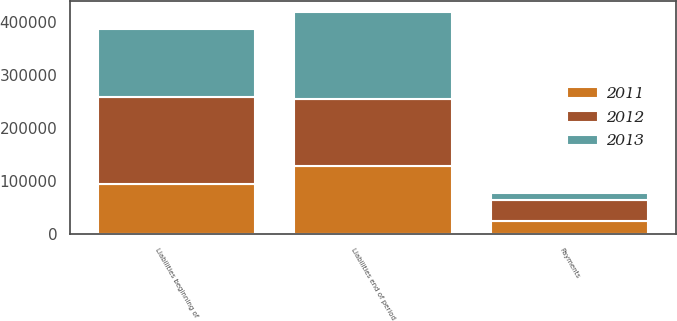Convert chart. <chart><loc_0><loc_0><loc_500><loc_500><stacked_bar_chart><ecel><fcel>Liabilities beginning of<fcel>Payments<fcel>Liabilities end of period<nl><fcel>2012<fcel>164280<fcel>39324<fcel>124956<nl><fcel>2013<fcel>128330<fcel>13075<fcel>164280<nl><fcel>2011<fcel>93057<fcel>24076<fcel>128330<nl></chart> 